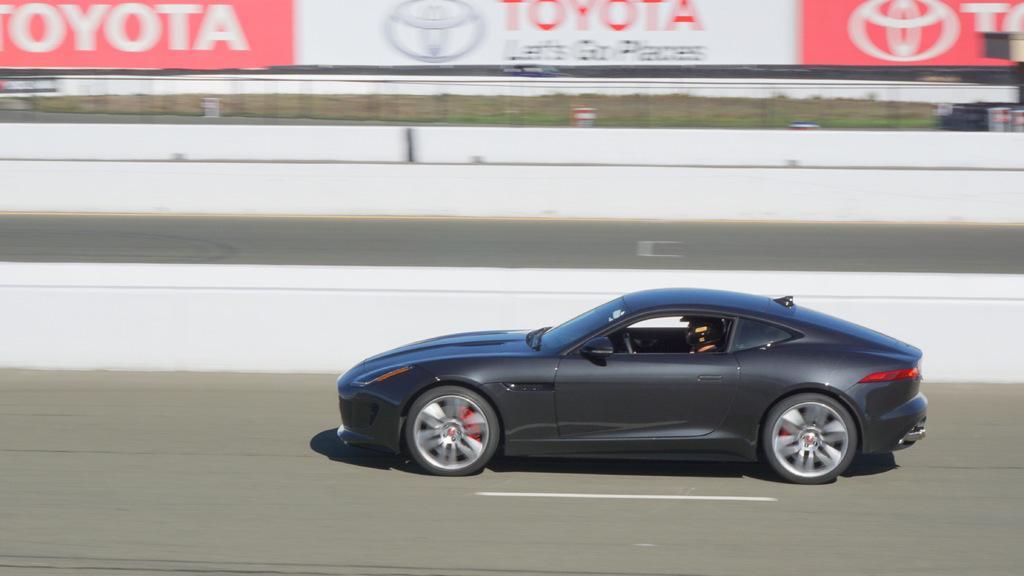In one or two sentences, can you explain what this image depicts? In this image there is a person driving the car on the road. In the background of the image there is a banner with some text on it. 